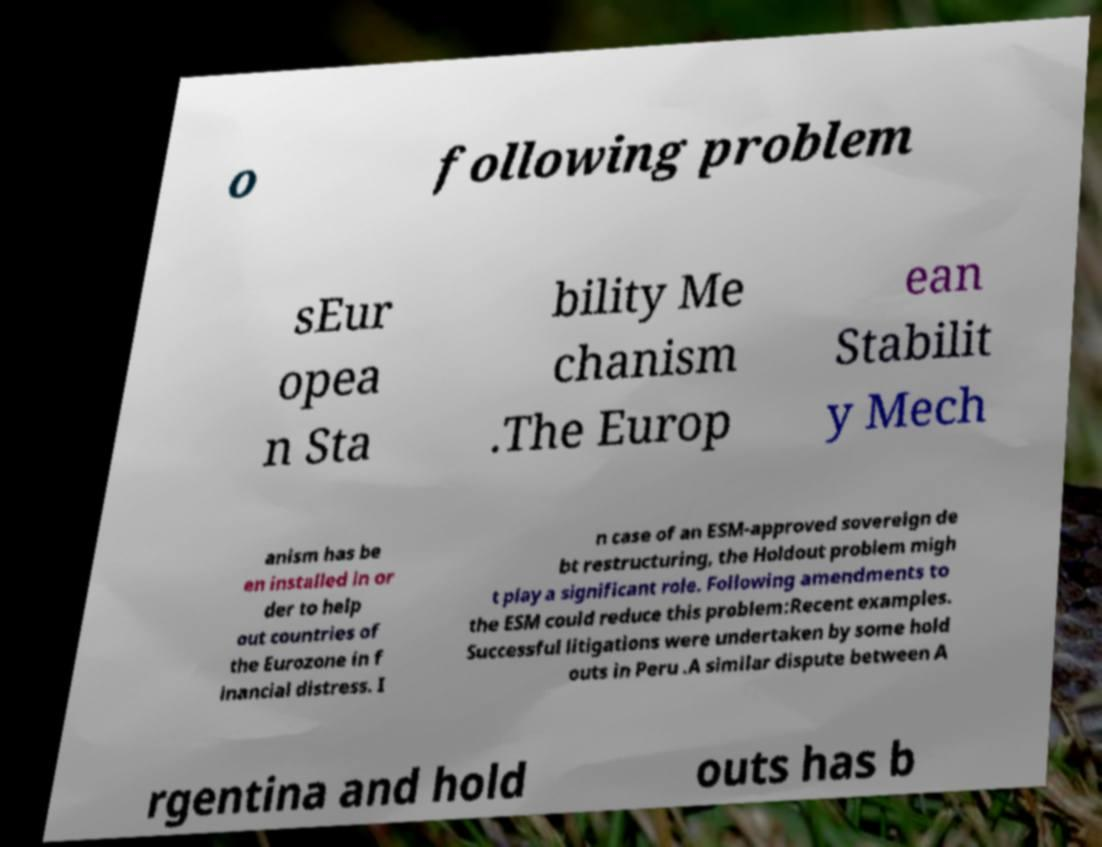Can you accurately transcribe the text from the provided image for me? o following problem sEur opea n Sta bility Me chanism .The Europ ean Stabilit y Mech anism has be en installed in or der to help out countries of the Eurozone in f inancial distress. I n case of an ESM-approved sovereign de bt restructuring, the Holdout problem migh t play a significant role. Following amendments to the ESM could reduce this problem:Recent examples. Successful litigations were undertaken by some hold outs in Peru .A similar dispute between A rgentina and hold outs has b 